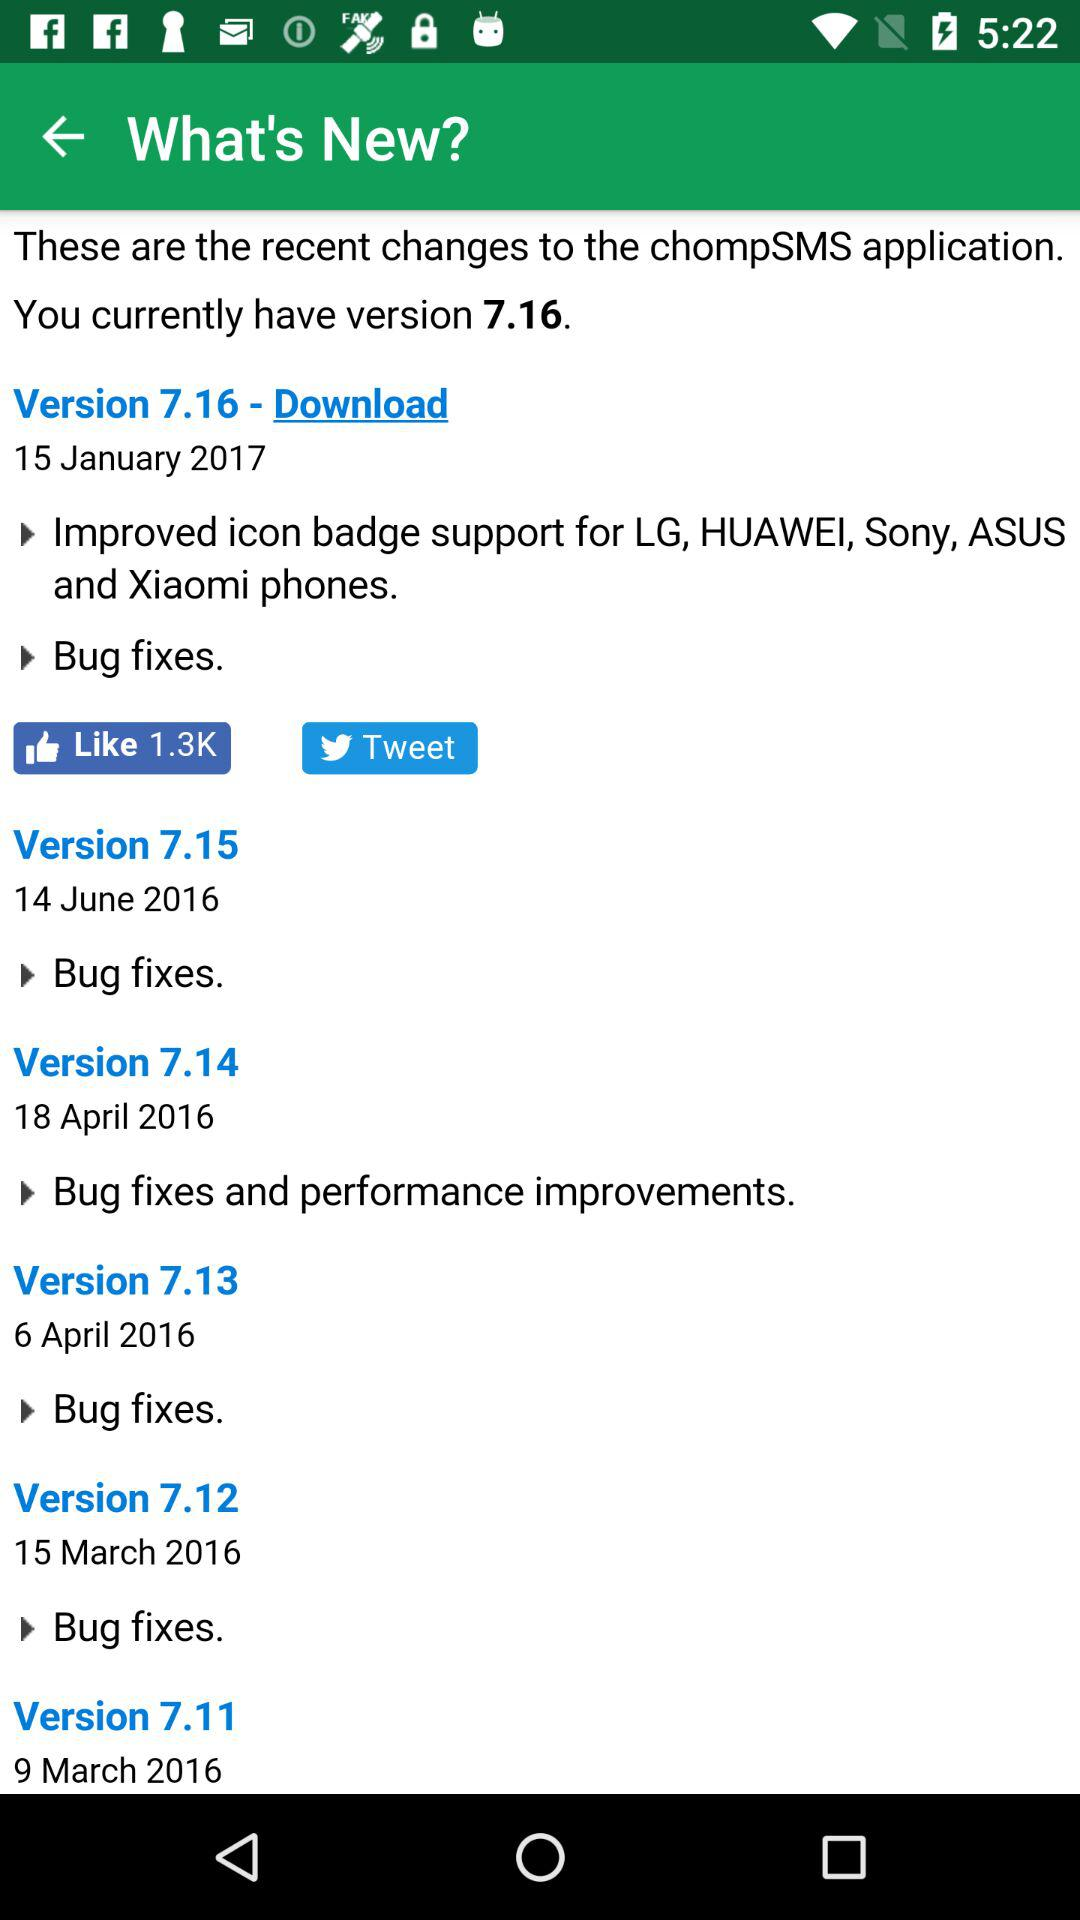What is the date given for version 7.15? The date given for version 7.15 is June 14, 2016. 